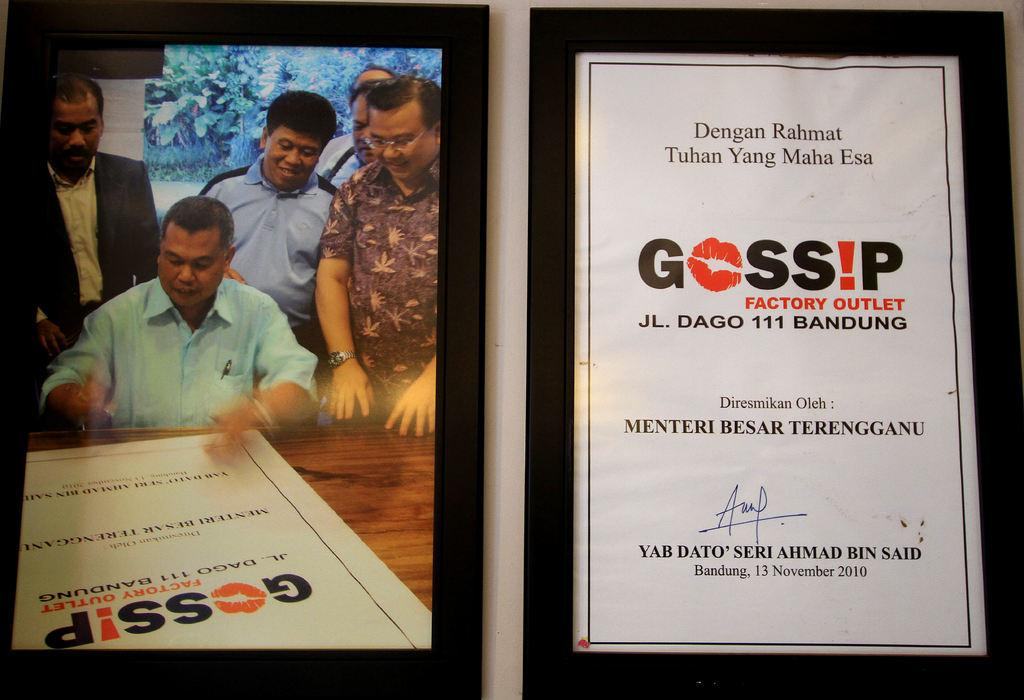<image>
Provide a brief description of the given image. A framed autographed poster for the Gossip Factory outlet next to a photograh of it being autographed. 